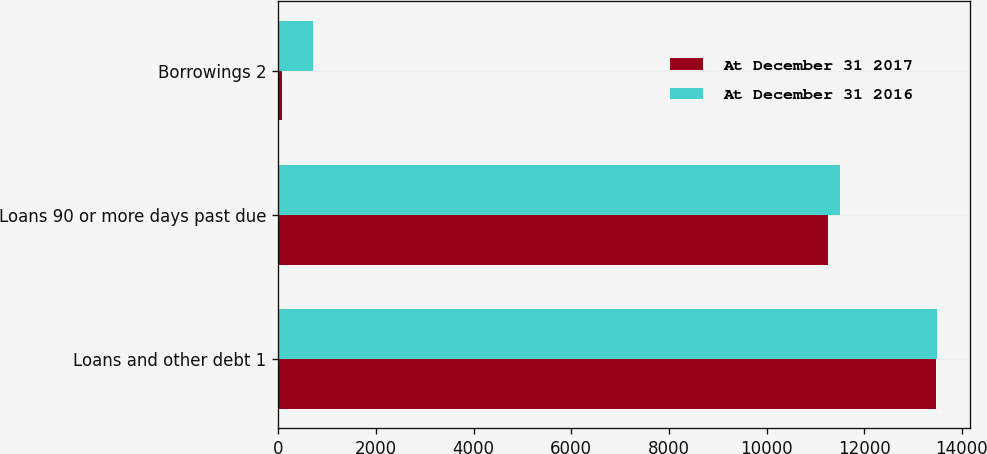Convert chart to OTSL. <chart><loc_0><loc_0><loc_500><loc_500><stacked_bar_chart><ecel><fcel>Loans and other debt 1<fcel>Loans 90 or more days past due<fcel>Borrowings 2<nl><fcel>At December 31 2017<fcel>13481<fcel>11253<fcel>71<nl><fcel>At December 31 2016<fcel>13495<fcel>11502<fcel>720<nl></chart> 